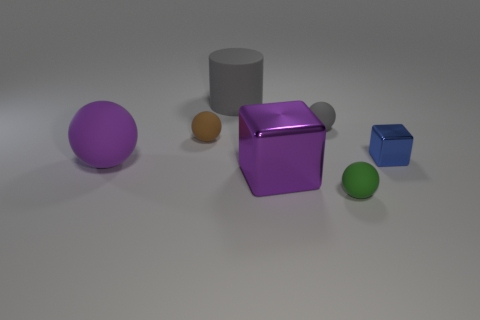Subtract all small balls. How many balls are left? 1 Subtract all brown balls. How many balls are left? 3 Subtract all cylinders. How many objects are left? 6 Add 3 small blue metal objects. How many objects exist? 10 Subtract 1 cylinders. How many cylinders are left? 0 Add 4 tiny brown matte balls. How many tiny brown matte balls are left? 5 Add 2 tiny blue blocks. How many tiny blue blocks exist? 3 Subtract 1 brown balls. How many objects are left? 6 Subtract all red spheres. Subtract all yellow cubes. How many spheres are left? 4 Subtract all gray cylinders. How many purple cubes are left? 1 